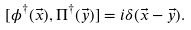Convert formula to latex. <formula><loc_0><loc_0><loc_500><loc_500>[ \phi ^ { \dagger } ( \vec { x } ) , \Pi ^ { \dagger } ( \vec { y } ) ] = i \delta ( \vec { x } - \vec { y } ) .</formula> 